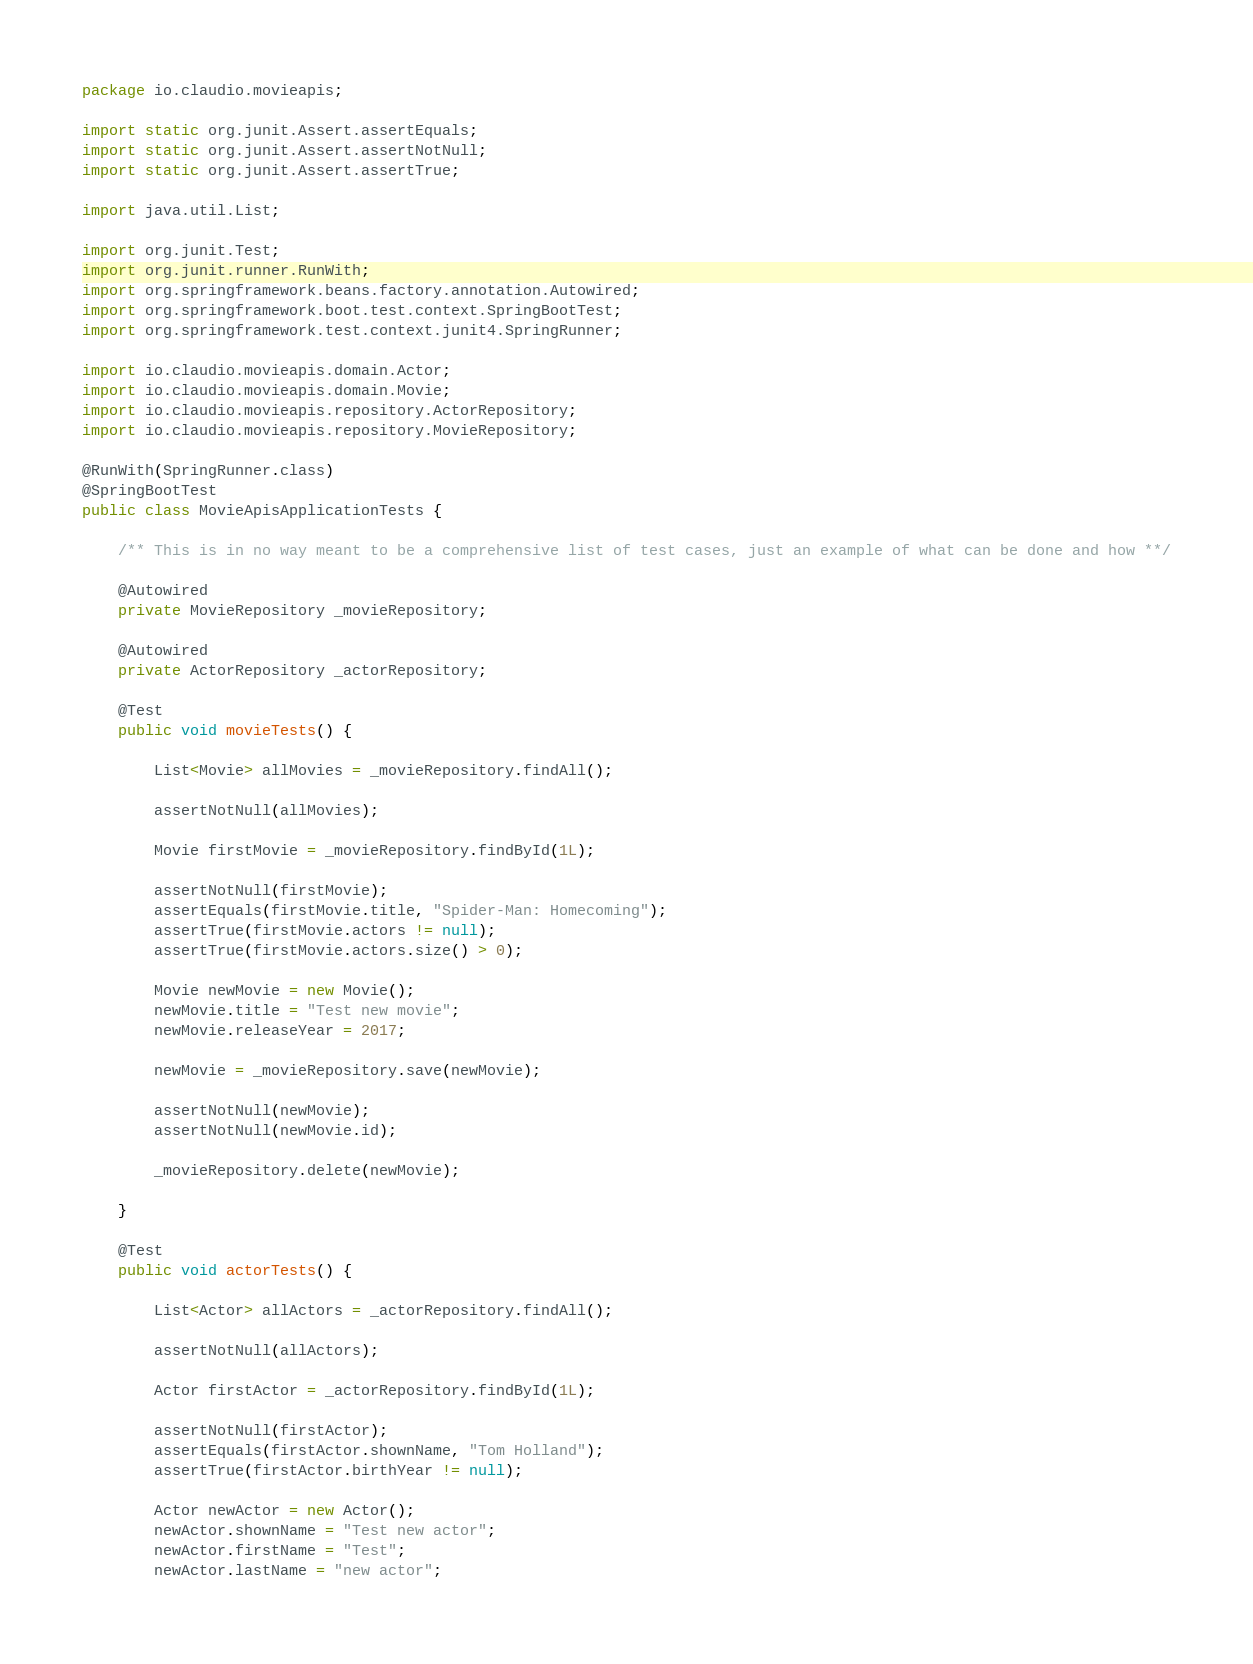Convert code to text. <code><loc_0><loc_0><loc_500><loc_500><_Java_>package io.claudio.movieapis;

import static org.junit.Assert.assertEquals;
import static org.junit.Assert.assertNotNull;
import static org.junit.Assert.assertTrue;

import java.util.List;

import org.junit.Test;
import org.junit.runner.RunWith;
import org.springframework.beans.factory.annotation.Autowired;
import org.springframework.boot.test.context.SpringBootTest;
import org.springframework.test.context.junit4.SpringRunner;

import io.claudio.movieapis.domain.Actor;
import io.claudio.movieapis.domain.Movie;
import io.claudio.movieapis.repository.ActorRepository;
import io.claudio.movieapis.repository.MovieRepository;

@RunWith(SpringRunner.class)
@SpringBootTest
public class MovieApisApplicationTests {

	/** This is in no way meant to be a comprehensive list of test cases, just an example of what can be done and how **/

	@Autowired
	private MovieRepository _movieRepository;

	@Autowired
	private ActorRepository _actorRepository;

	@Test
	public void movieTests() {

		List<Movie> allMovies = _movieRepository.findAll();

		assertNotNull(allMovies);

		Movie firstMovie = _movieRepository.findById(1L);

		assertNotNull(firstMovie);
		assertEquals(firstMovie.title, "Spider-Man: Homecoming");
		assertTrue(firstMovie.actors != null);
		assertTrue(firstMovie.actors.size() > 0);

		Movie newMovie = new Movie();
		newMovie.title = "Test new movie";
		newMovie.releaseYear = 2017;

		newMovie = _movieRepository.save(newMovie);

		assertNotNull(newMovie);
		assertNotNull(newMovie.id);

		_movieRepository.delete(newMovie);

	}

	@Test
	public void actorTests() {

		List<Actor> allActors = _actorRepository.findAll();

		assertNotNull(allActors);

		Actor firstActor = _actorRepository.findById(1L);

		assertNotNull(firstActor);
		assertEquals(firstActor.shownName, "Tom Holland");
		assertTrue(firstActor.birthYear != null);

		Actor newActor = new Actor();
		newActor.shownName = "Test new actor";
		newActor.firstName = "Test";
		newActor.lastName = "new actor";</code> 